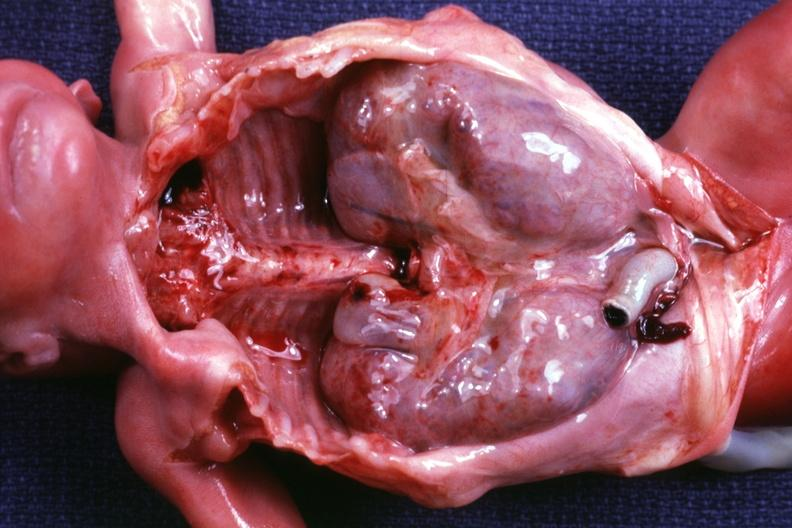how is kidneys in situ with other organs removed demonstration of size of kidneys?
Answer the question using a single word or phrase. Dramatic 